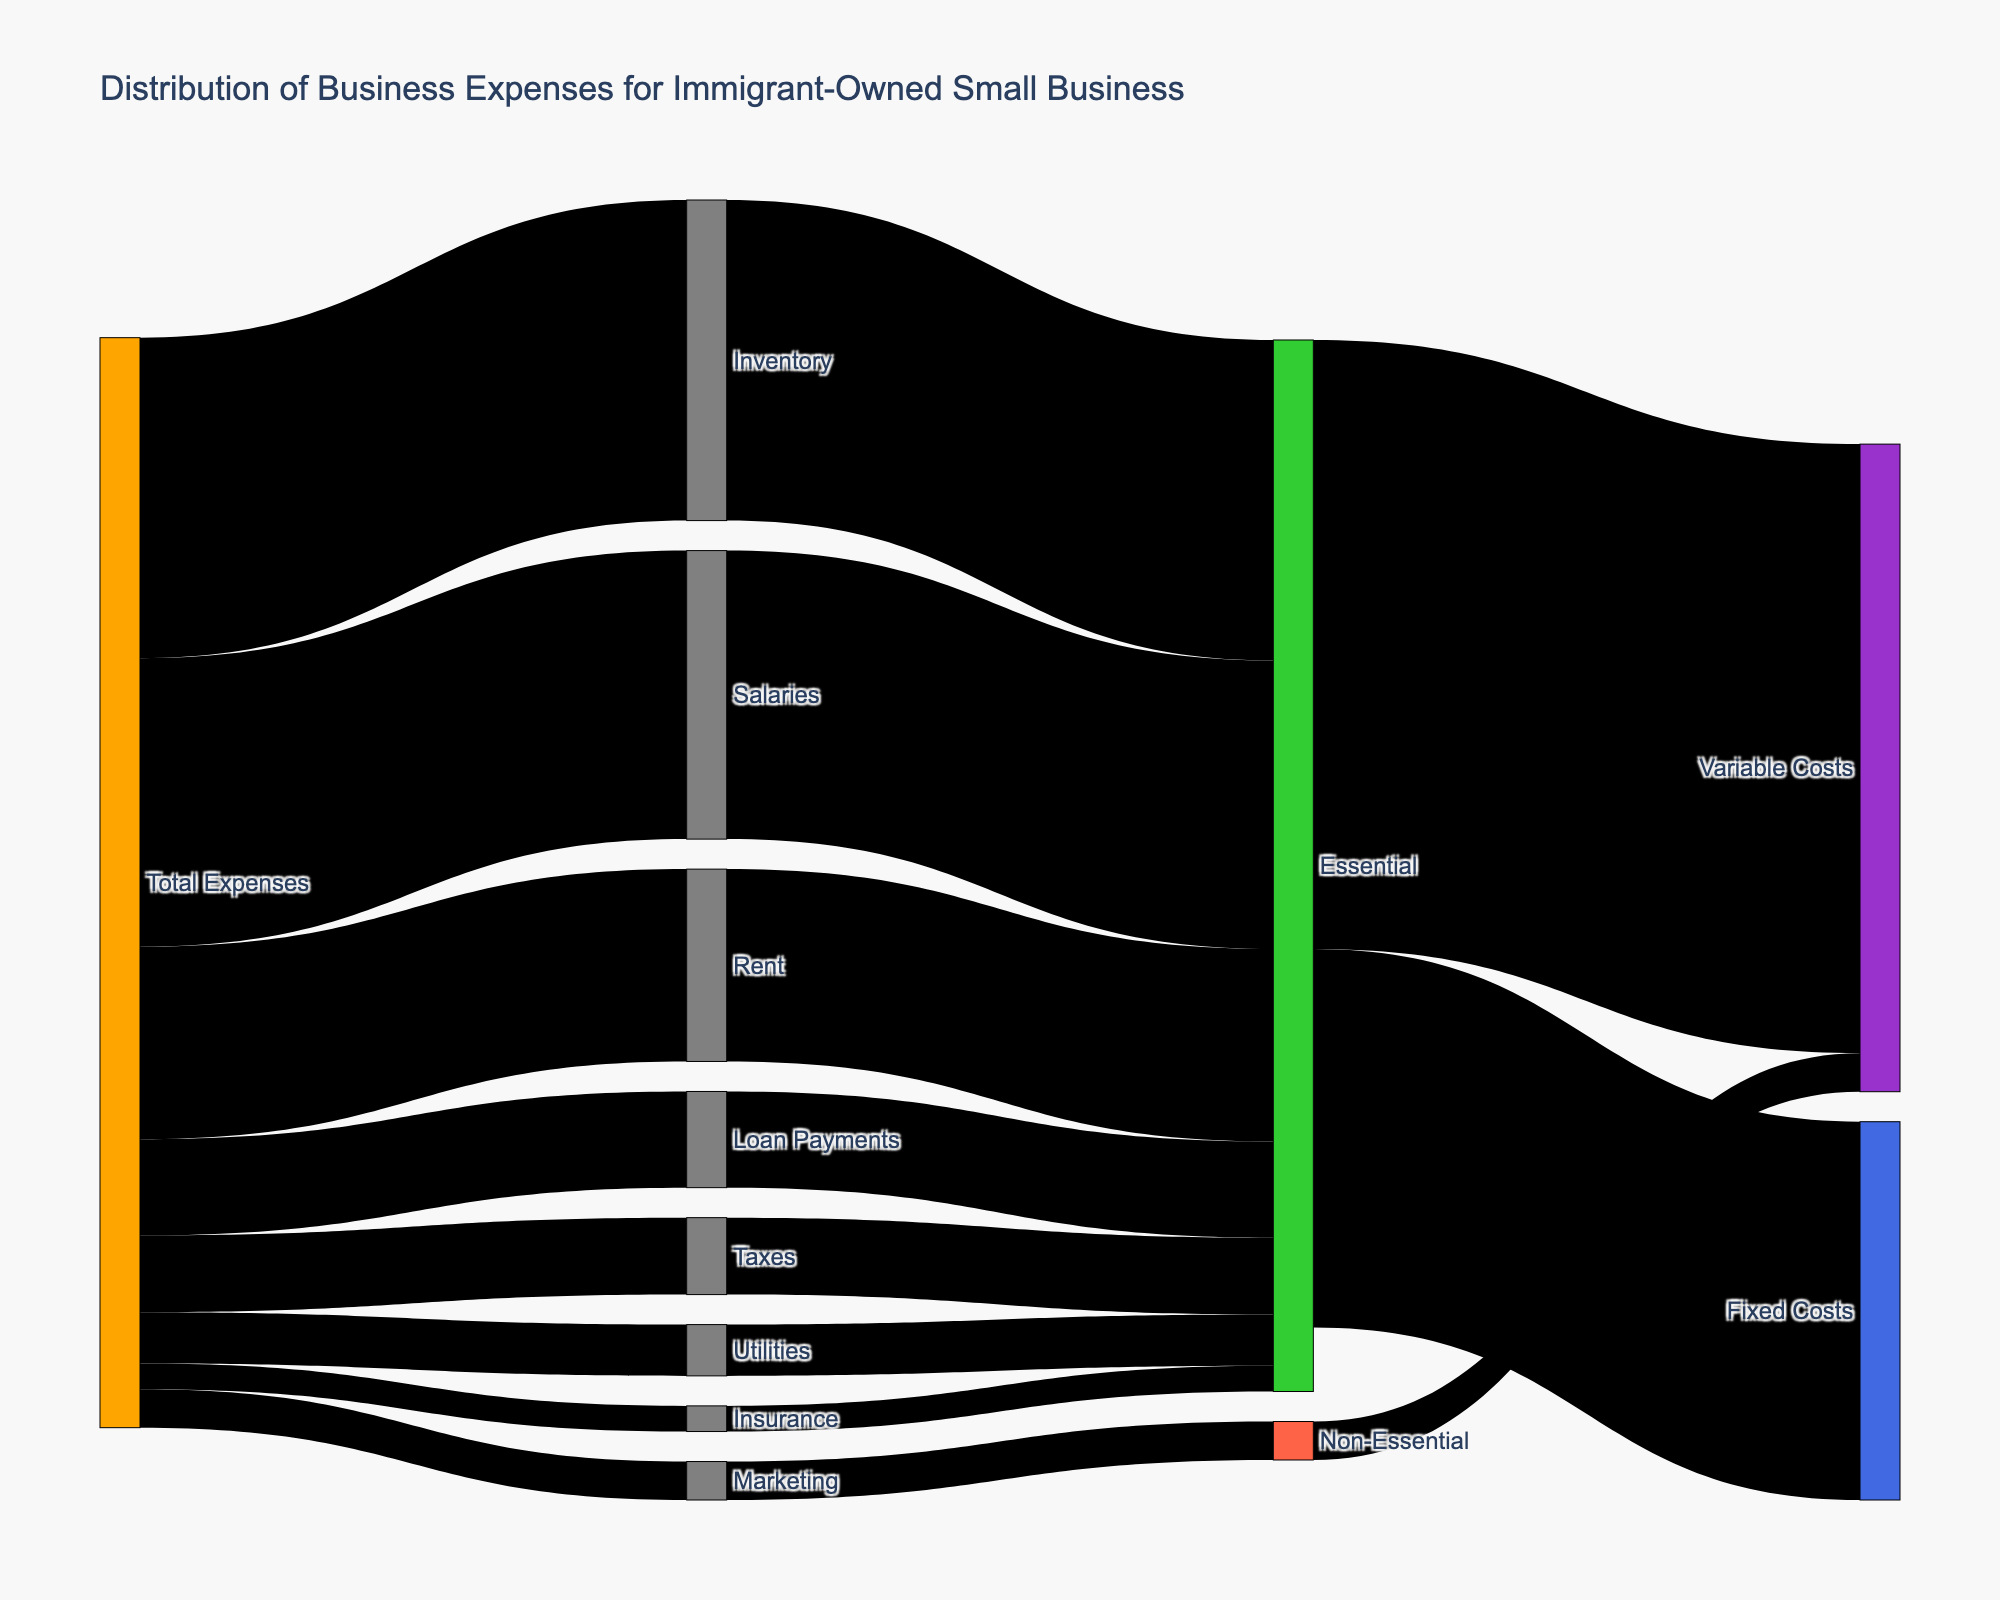What is the title of the diagram? The diagram title is located at the top of the visualization. It reads "Distribution of Business Expenses for Immigrant-Owned Small Business".
Answer: Distribution of Business Expenses for Immigrant-Owned Small Business What are the two main categories of expenses? The diagram branches the "Total Expenses" into "Essential" and "Non-Essential" categories.
Answer: Essential, Non-Essential How much is spent on Rent? Following the link from "Total Expenses" to "Rent", we can see that the value is 3000.
Answer: 3000 Which expense category has the highest cost, and how much is it? The link from "Total Expenses" to "Inventory" shows the highest value, which is 5000.
Answer: Inventory, 5000 What percentage of the total expenses are considered Essential? Adding up all values under the "Essential" category: Rent (3000) + Utilities (800) + Inventory (5000) + Salaries (4500) + Insurance (400) + Taxes (1200) + Loan Payments (1500) = 16400. The total of all expenses is the sum of "Total Expenses" equals 17000. The percentage is (16400/17000) * 100 = 96.47%.
Answer: 96.47% Which fixed and variable cost has the highest value among Essential expenses? Among the Essential expenses, Fixed Costs has Salaries (4500), and Variable Costs has Inventory (5000). Inventory has the highest value.
Answer: Inventory How do the fixed costs compare to the variable costs in the Essential category? The sum of Fixed Costs for Essential is 5900 (sum of Rent and Insurance), and the sum of Variable Costs for Essential is 9500 (sum of Inventory, Salaries, Taxes, and Loan Payments). Variable Costs exceed Fixed Costs by 9500 - 5900 = 3600.
Answer: Variable Costs exceed by 3600 What is the combined total of Marketing and Insurance expenses? Marketing expenses are 600, and Insurance expenses are 400. Combining them results in 600 + 400 = 1000.
Answer: 1000 Which expense belongs to the Non-Essential category? The branch labeled "Non-Essential" links to Marketing, showing it belongs to the Non-Essential category.
Answer: Marketing What is the total amount spent on Fixed and Variable Costs? Adding all Fixed Costs and Variable Costs: Fixed Costs (5900, only from Essential) and Variable Costs (9500 from Essential + 600 from Non-Essential) results in 5900 + 10100 = 16000.
Answer: 16000 